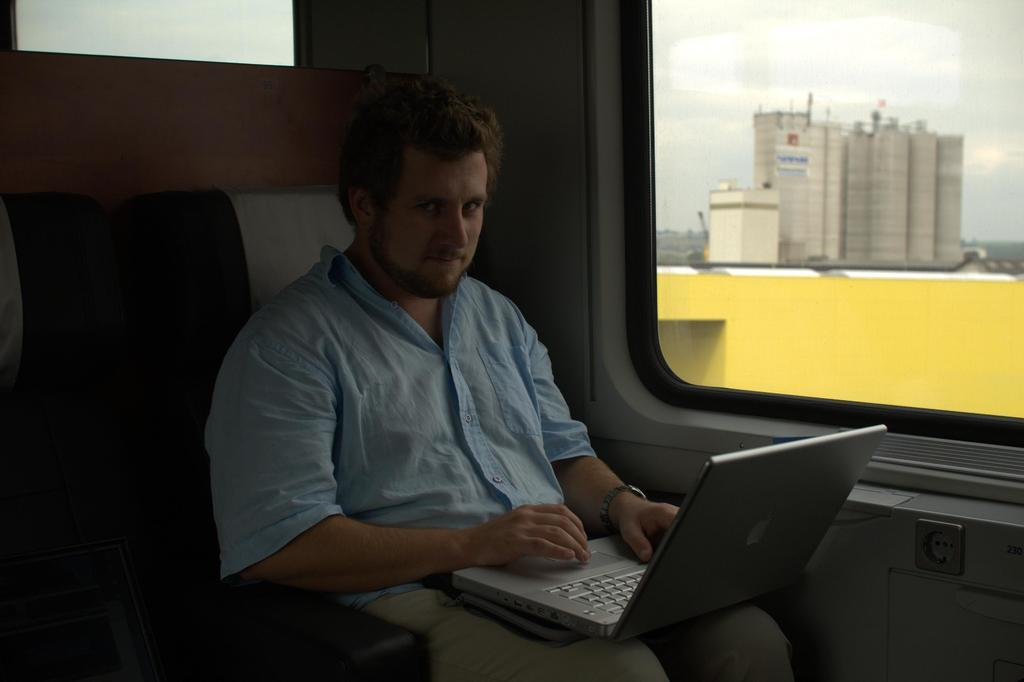Who is present in the image? There is a man in the image. What is the man doing in the image? The man is sitting on a chair and holding a laptop in his lap. What can be seen in the background of the image? There is a glass window in the background of the image, and buildings are visible through it. What type of drain is visible in the image? There is no drain present in the image. What is the sun's position in the image? The sun is not visible in the image, as it is an indoor scene with a glass window and buildings visible through it. 